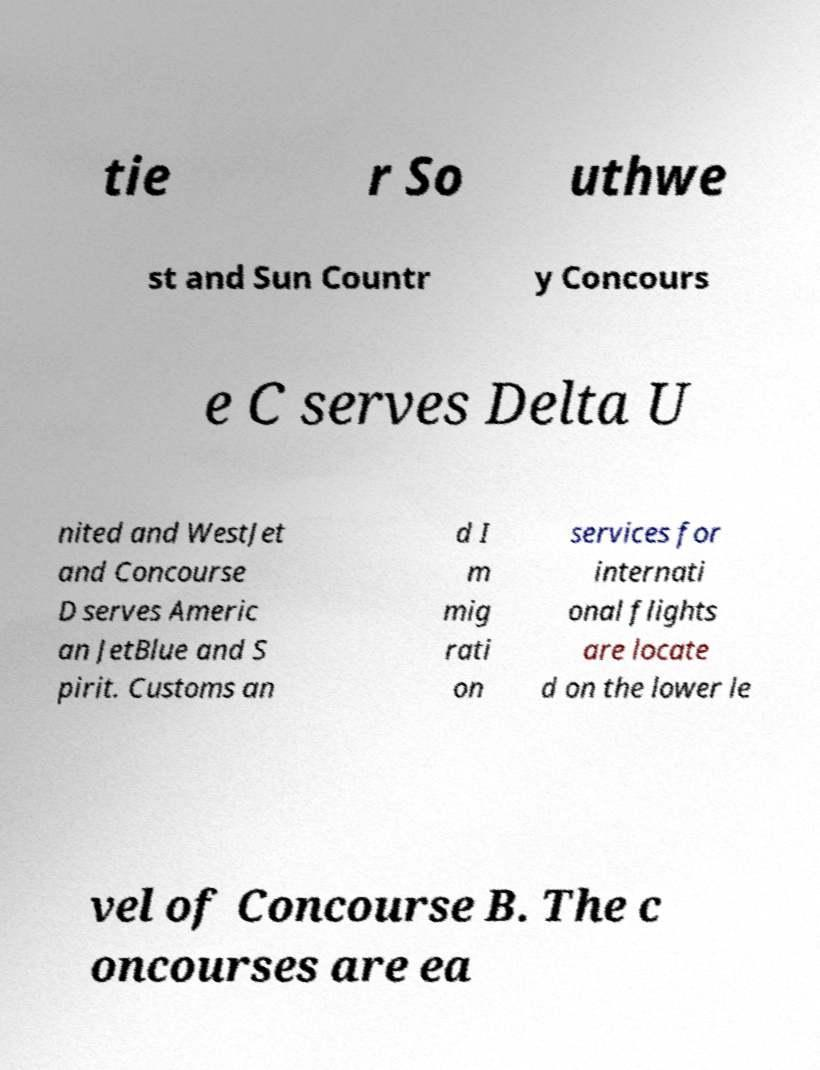There's text embedded in this image that I need extracted. Can you transcribe it verbatim? tie r So uthwe st and Sun Countr y Concours e C serves Delta U nited and WestJet and Concourse D serves Americ an JetBlue and S pirit. Customs an d I m mig rati on services for internati onal flights are locate d on the lower le vel of Concourse B. The c oncourses are ea 